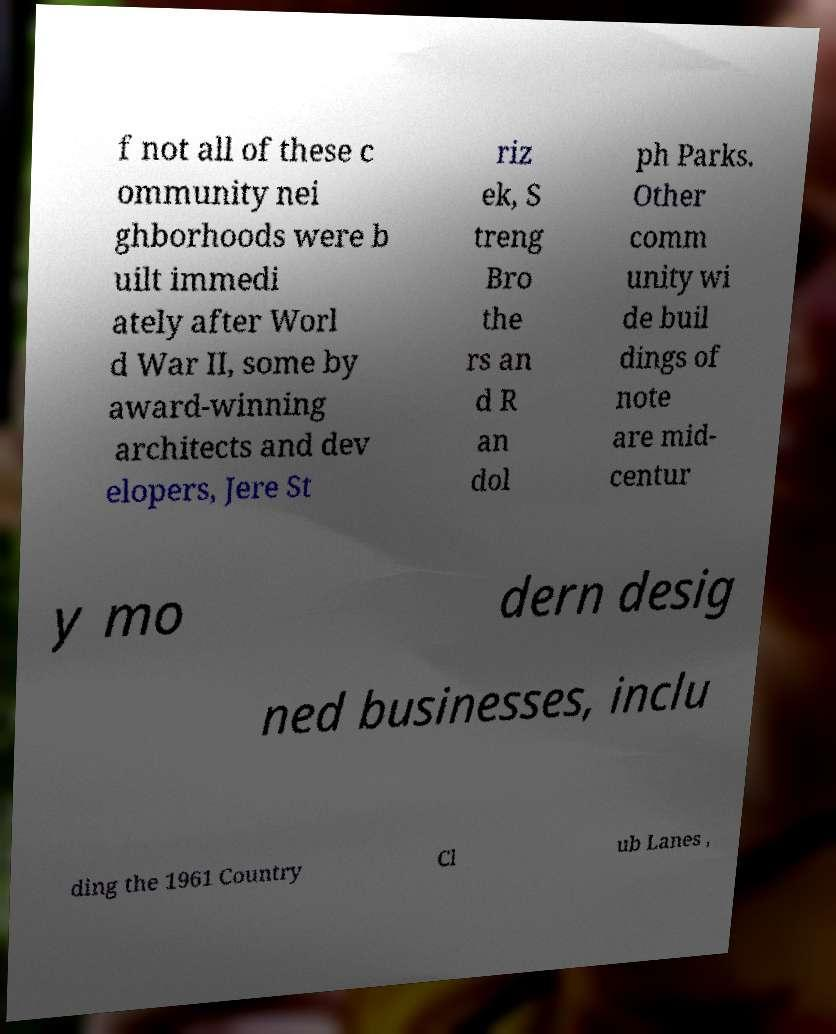What messages or text are displayed in this image? I need them in a readable, typed format. f not all of these c ommunity nei ghborhoods were b uilt immedi ately after Worl d War II, some by award-winning architects and dev elopers, Jere St riz ek, S treng Bro the rs an d R an dol ph Parks. Other comm unity wi de buil dings of note are mid- centur y mo dern desig ned businesses, inclu ding the 1961 Country Cl ub Lanes , 